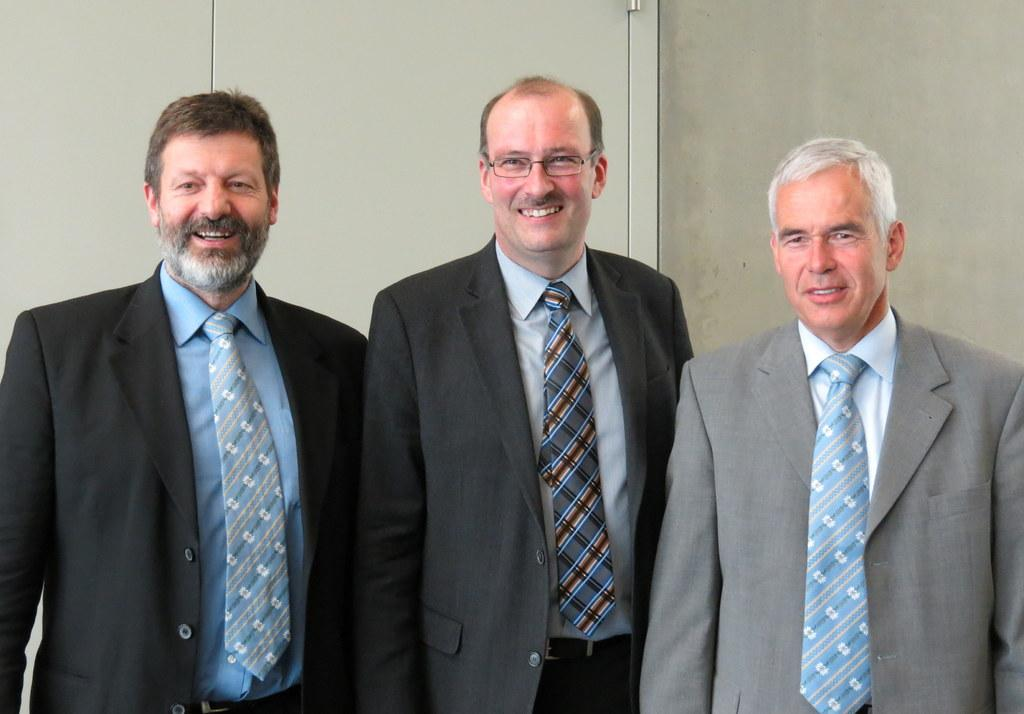What are the people in the image doing? The people in the image are standing and smiling. What type of clothing are the people wearing? The people are wearing coats and ties. Can you describe any specific accessory one of the people is wearing? One person is wearing glasses. What can be seen in the background of the image? There is a wall in the background of the image. What type of flowers can be seen growing on the trail in the image? There is no trail or flowers present in the image; it features people standing and smiling. 